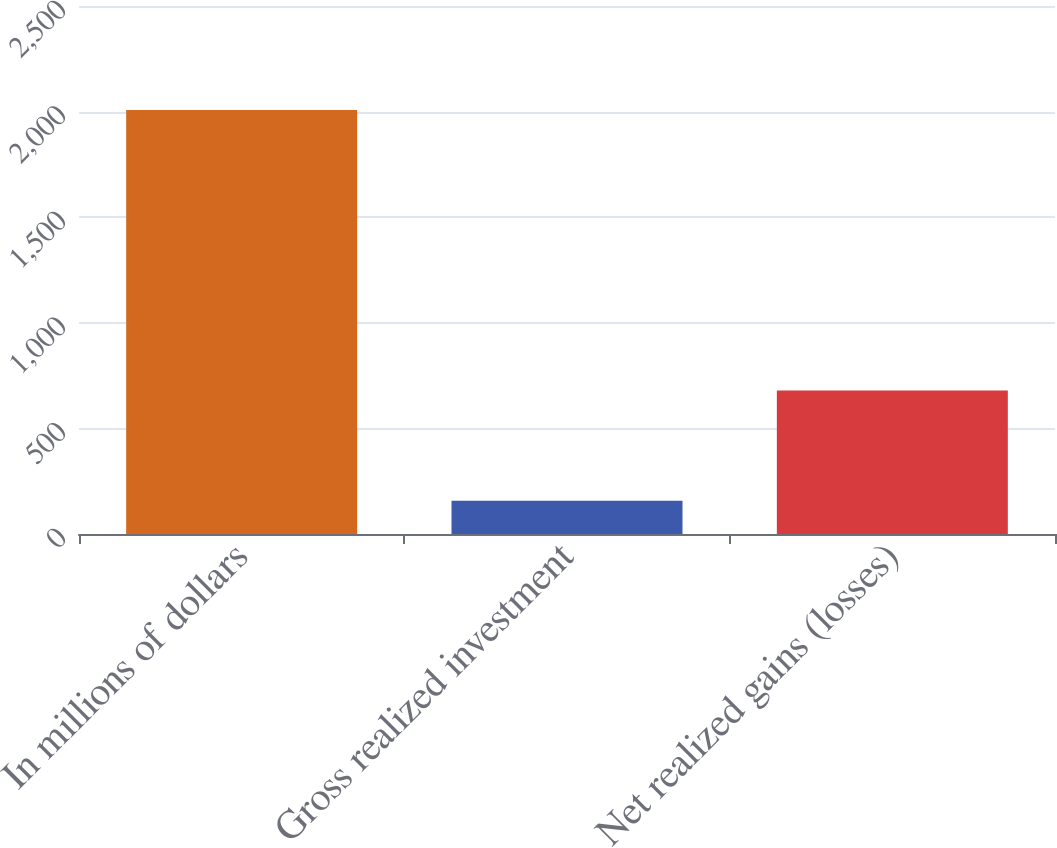Convert chart. <chart><loc_0><loc_0><loc_500><loc_500><bar_chart><fcel>In millions of dollars<fcel>Gross realized investment<fcel>Net realized gains (losses)<nl><fcel>2008<fcel>158<fcel>679<nl></chart> 